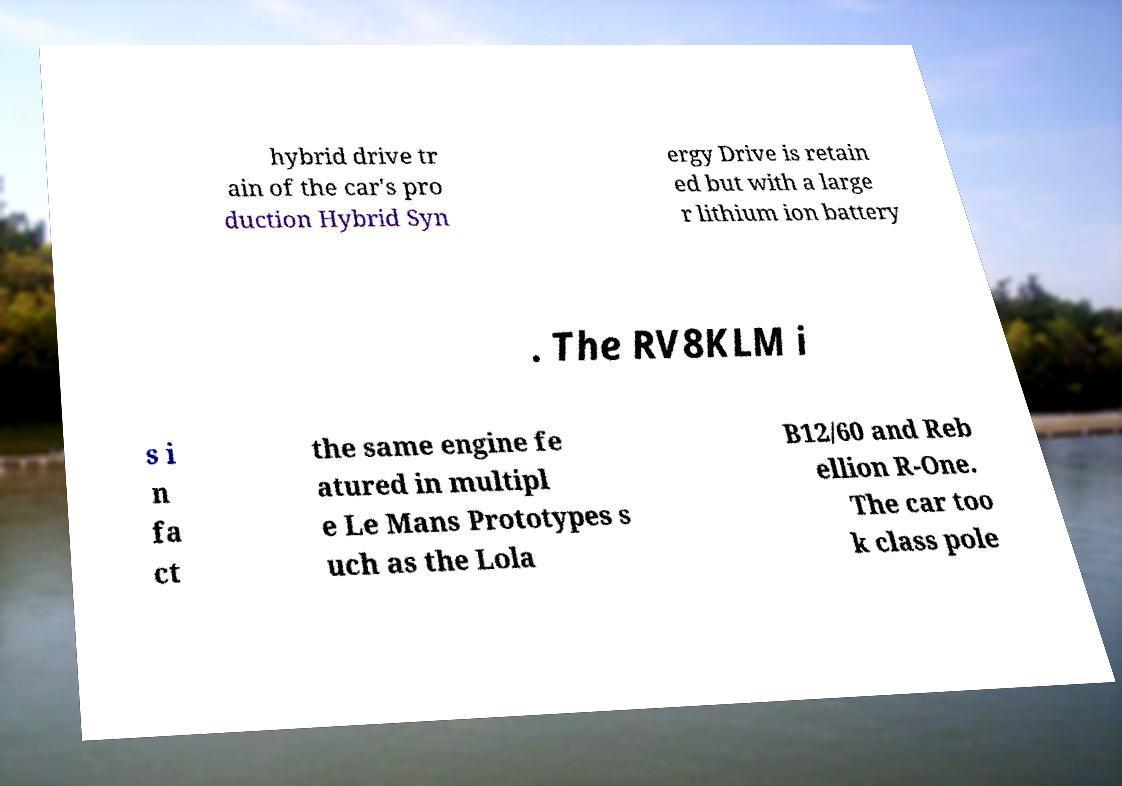Please read and relay the text visible in this image. What does it say? hybrid drive tr ain of the car's pro duction Hybrid Syn ergy Drive is retain ed but with a large r lithium ion battery . The RV8KLM i s i n fa ct the same engine fe atured in multipl e Le Mans Prototypes s uch as the Lola B12/60 and Reb ellion R-One. The car too k class pole 